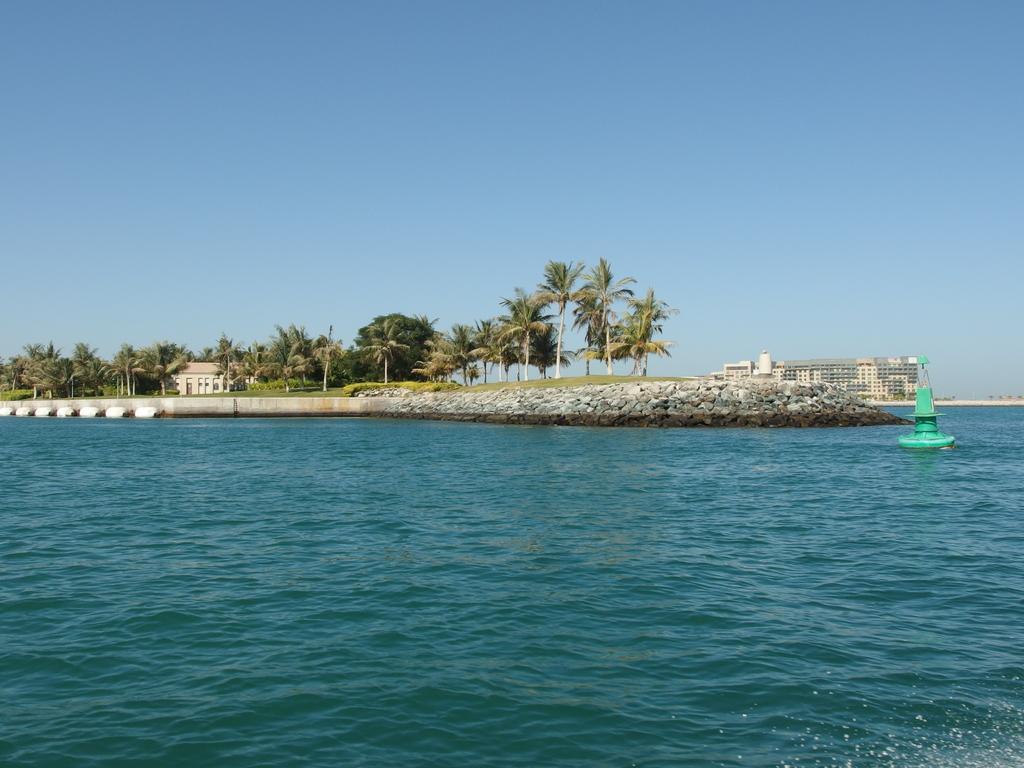Please provide a concise description of this image. There is water. In the water there is a green color thing. Also there is a rock wall. In the background there are trees, buildings and sky. 